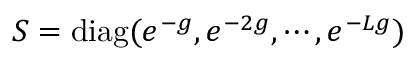Convert formula to latex. <formula><loc_0><loc_0><loc_500><loc_500>S = d i a g ( e ^ { - g } , e ^ { - 2 g } , \cdots , e ^ { - L g } )</formula> 